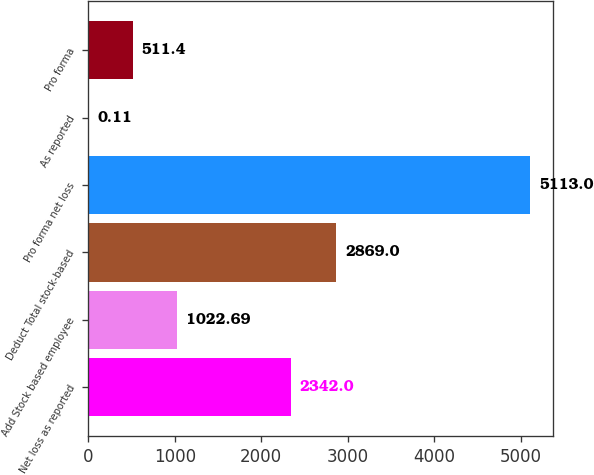Convert chart to OTSL. <chart><loc_0><loc_0><loc_500><loc_500><bar_chart><fcel>Net loss as reported<fcel>Add Stock based employee<fcel>Deduct Total stock-based<fcel>Pro forma net loss<fcel>As reported<fcel>Pro forma<nl><fcel>2342<fcel>1022.69<fcel>2869<fcel>5113<fcel>0.11<fcel>511.4<nl></chart> 